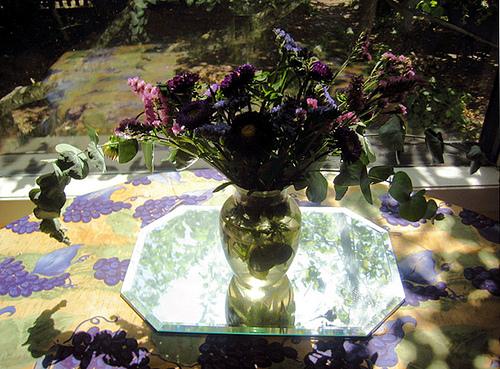What is being reflected in the mirror?
Short answer required. Flowers. Are these flowers dying?
Quick response, please. Yes. What color is the vase?
Write a very short answer. Clear. 